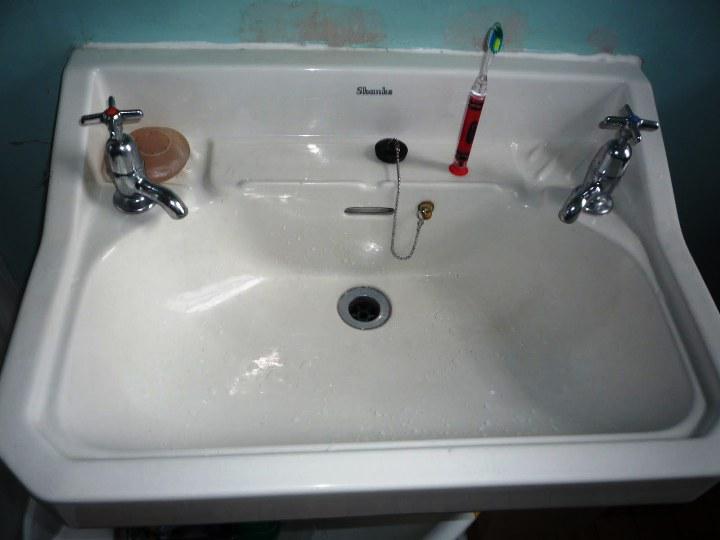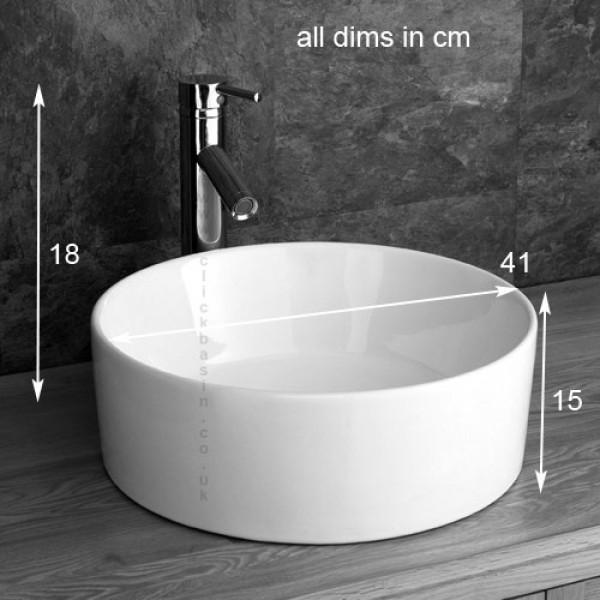The first image is the image on the left, the second image is the image on the right. For the images shown, is this caption "A bathroom double sink installation has one upright chrome faucet fixture situated behind the bowl of each sink" true? Answer yes or no. No. The first image is the image on the left, the second image is the image on the right. For the images shown, is this caption "There are two basins on the counter in the image on the right." true? Answer yes or no. No. 